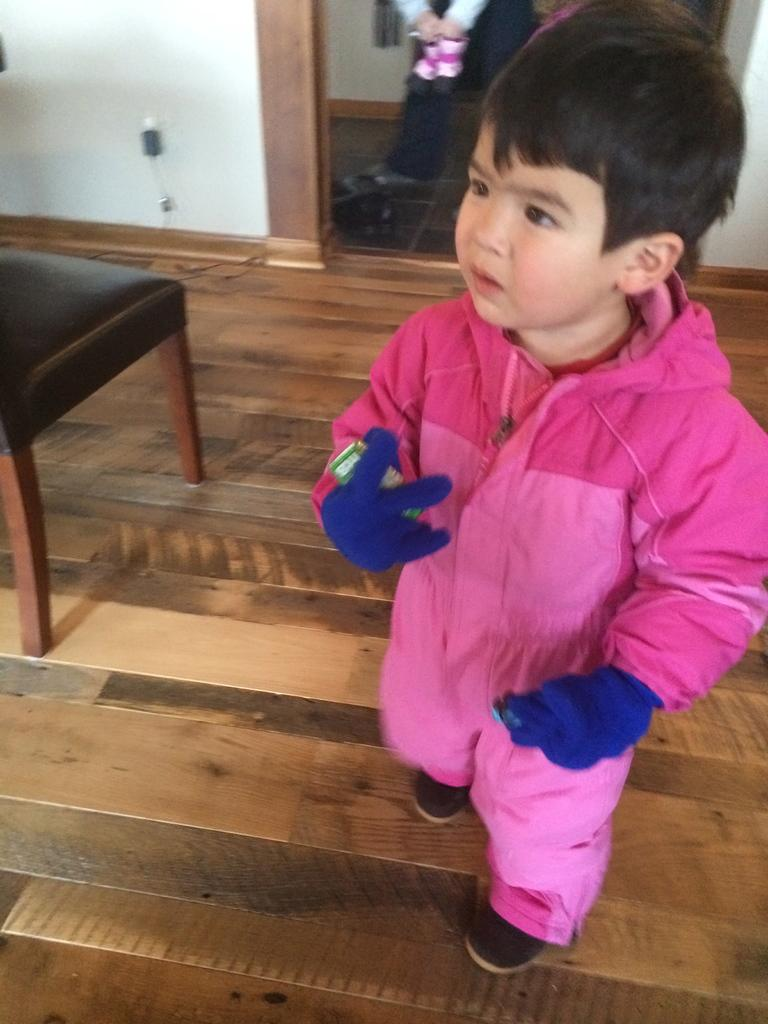Who is the main subject in the image? There is a boy in the image. What is the boy wearing? The boy is wearing a pink dress and gloves. Where is the boy standing? The boy is standing on the floor. What can be seen in the background of the image? There is a plain wall and a chair in the background of the image. What type of ring can be seen on the boy's finger in the image? There is no ring visible on the boy's finger in the image. Are there any dinosaurs present in the image? No, there are no dinosaurs present in the image. 